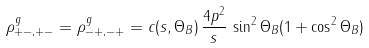<formula> <loc_0><loc_0><loc_500><loc_500>\rho _ { + - , + - } ^ { g } = \rho _ { - + , - + } ^ { g } = c ( s , \Theta _ { B } ) \, \frac { 4 p ^ { 2 } } { s } \, \sin ^ { 2 } \Theta _ { B } ( 1 + \cos ^ { 2 } \Theta _ { B } )</formula> 